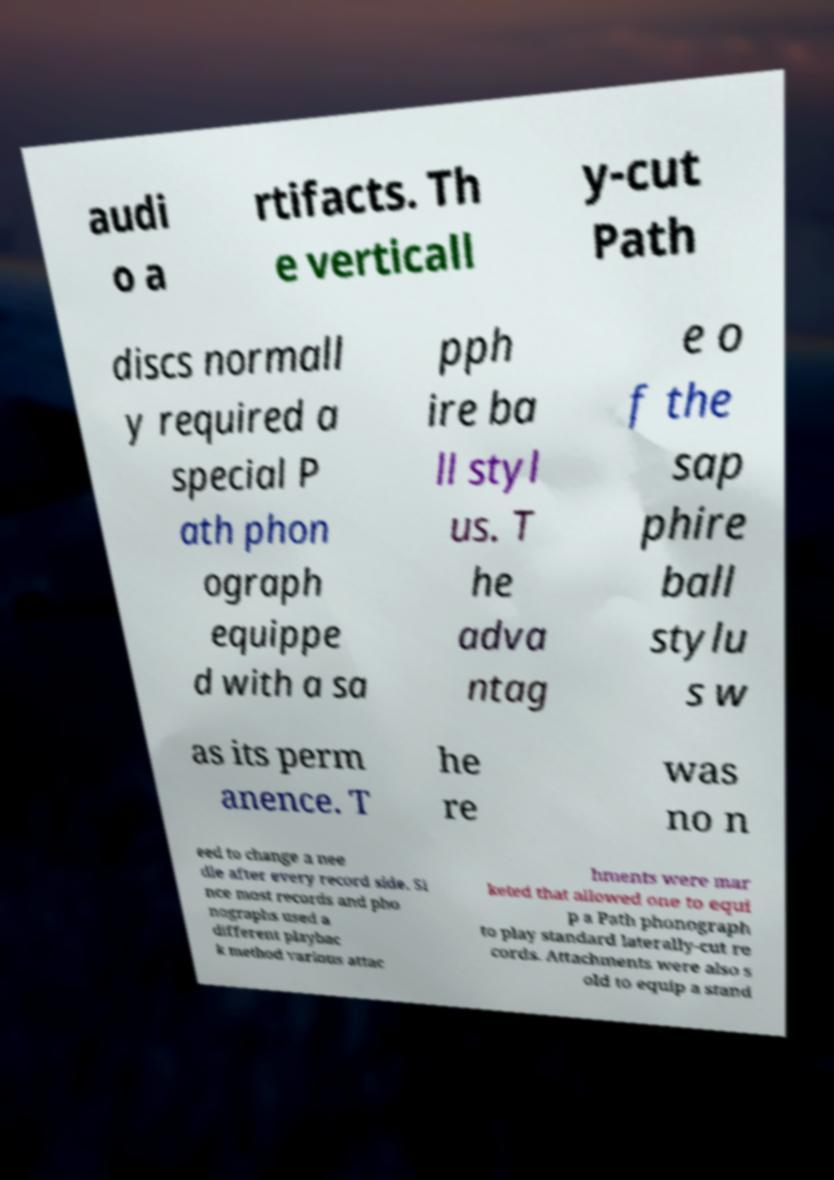There's text embedded in this image that I need extracted. Can you transcribe it verbatim? audi o a rtifacts. Th e verticall y-cut Path discs normall y required a special P ath phon ograph equippe d with a sa pph ire ba ll styl us. T he adva ntag e o f the sap phire ball stylu s w as its perm anence. T he re was no n eed to change a nee dle after every record side. Si nce most records and pho nographs used a different playbac k method various attac hments were mar keted that allowed one to equi p a Path phonograph to play standard laterally-cut re cords. Attachments were also s old to equip a stand 